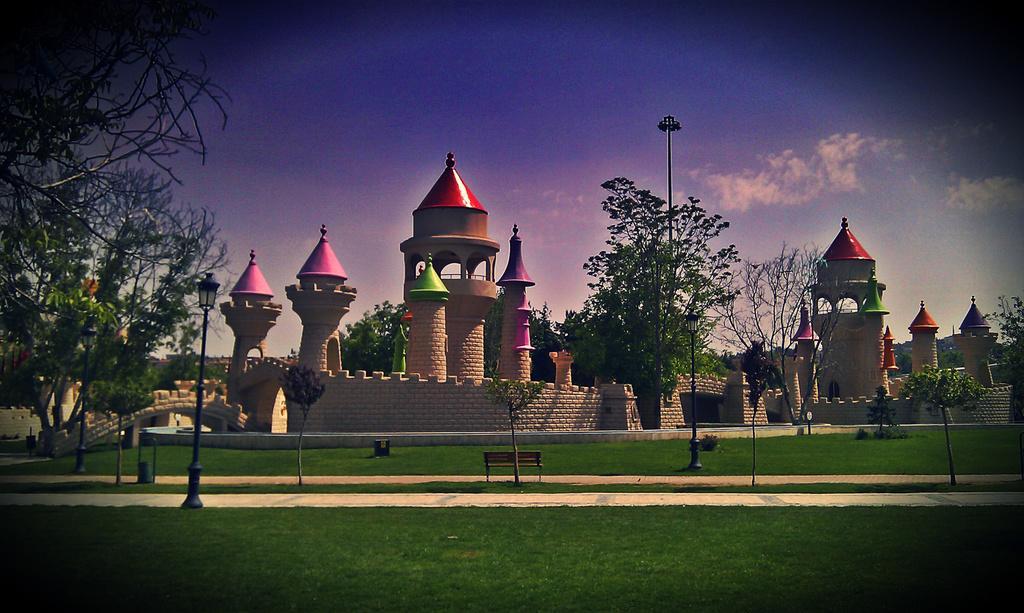Can you describe this image briefly? In the picture I can see a fort, fence wall, the grass, plants, trees, pole lights, a bench and some other objects. In the background I can see the sky. 